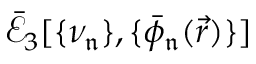Convert formula to latex. <formula><loc_0><loc_0><loc_500><loc_500>\mathcal { \bar { E } } _ { 3 } [ \{ \nu _ { \mathfrak { n } } \} , \{ \bar { \phi } _ { \mathfrak { n } } ( \vec { r } ) \} ]</formula> 